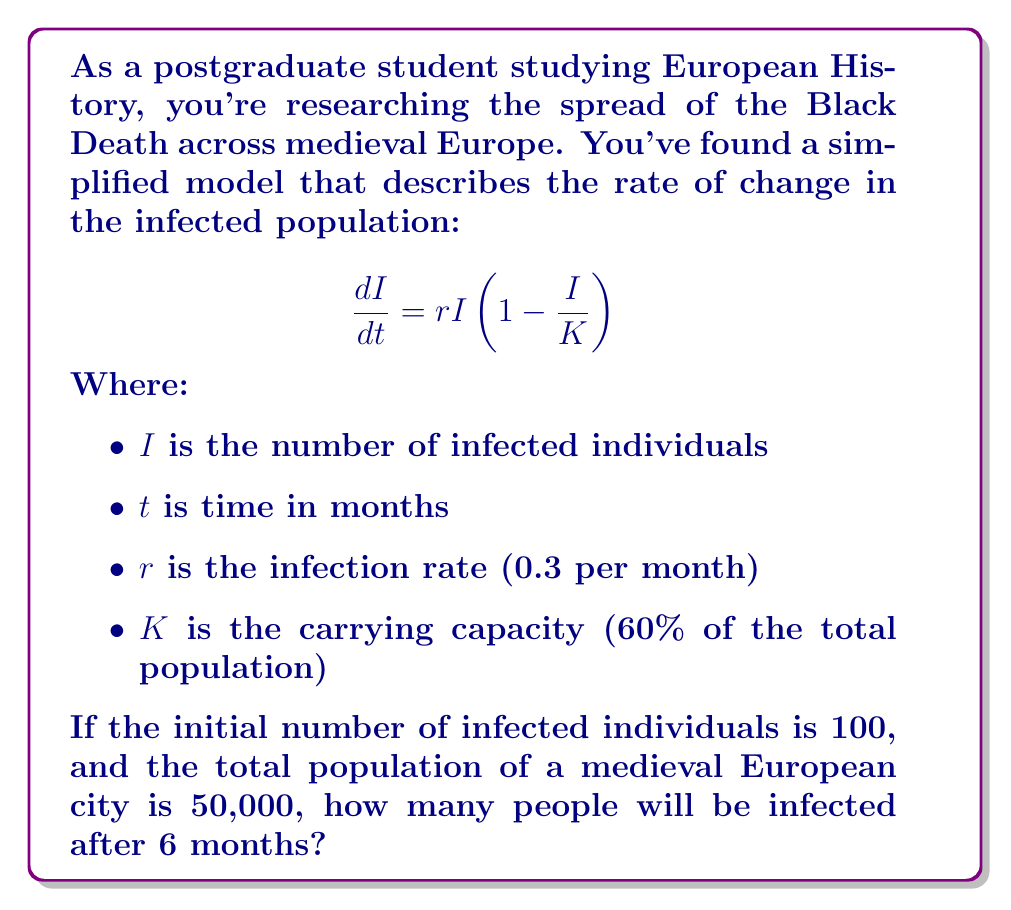Show me your answer to this math problem. Let's approach this step-by-step:

1) First, we need to identify the given parameters:
   $r = 0.3$ per month
   $K = 0.6 \times 50,000 = 30,000$ infected individuals
   $I_0 = 100$ (initial number of infected)
   $t = 6$ months

2) The given equation is a logistic growth model. Its solution is:

   $$I(t) = \frac{K}{1 + (\frac{K}{I_0} - 1)e^{-rt}}$$

3) Let's substitute our values:

   $$I(6) = \frac{30000}{1 + (\frac{30000}{100} - 1)e^{-0.3 \times 6}}$$

4) Simplify:
   $$I(6) = \frac{30000}{1 + 299e^{-1.8}}$$

5) Calculate:
   $e^{-1.8} \approx 0.1653$
   $299 \times 0.1653 \approx 49.4247$

6) Therefore:
   $$I(6) = \frac{30000}{1 + 49.4247} \approx 594.1$$

7) Since we're dealing with people, we round to the nearest whole number.
Answer: 594 people 